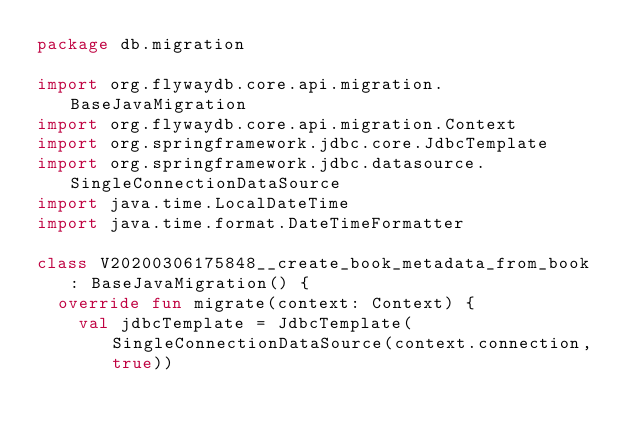Convert code to text. <code><loc_0><loc_0><loc_500><loc_500><_Kotlin_>package db.migration

import org.flywaydb.core.api.migration.BaseJavaMigration
import org.flywaydb.core.api.migration.Context
import org.springframework.jdbc.core.JdbcTemplate
import org.springframework.jdbc.datasource.SingleConnectionDataSource
import java.time.LocalDateTime
import java.time.format.DateTimeFormatter

class V20200306175848__create_book_metadata_from_book : BaseJavaMigration() {
  override fun migrate(context: Context) {
    val jdbcTemplate = JdbcTemplate(SingleConnectionDataSource(context.connection, true))
</code> 